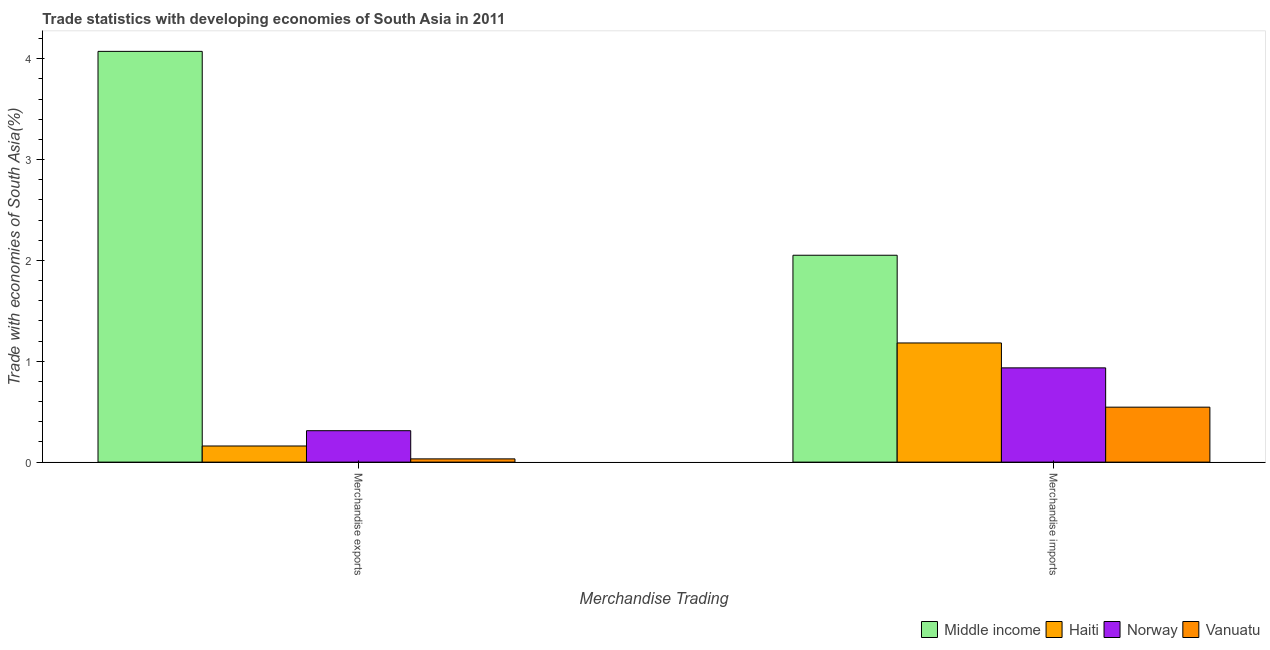Are the number of bars on each tick of the X-axis equal?
Make the answer very short. Yes. How many bars are there on the 2nd tick from the left?
Your answer should be very brief. 4. What is the label of the 1st group of bars from the left?
Keep it short and to the point. Merchandise exports. What is the merchandise exports in Norway?
Make the answer very short. 0.31. Across all countries, what is the maximum merchandise exports?
Provide a succinct answer. 4.07. Across all countries, what is the minimum merchandise exports?
Provide a succinct answer. 0.03. In which country was the merchandise imports minimum?
Offer a very short reply. Vanuatu. What is the total merchandise exports in the graph?
Keep it short and to the point. 4.58. What is the difference between the merchandise imports in Haiti and that in Middle income?
Ensure brevity in your answer.  -0.87. What is the difference between the merchandise exports in Vanuatu and the merchandise imports in Middle income?
Make the answer very short. -2.02. What is the average merchandise exports per country?
Ensure brevity in your answer.  1.14. What is the difference between the merchandise exports and merchandise imports in Middle income?
Offer a terse response. 2.02. What is the ratio of the merchandise imports in Vanuatu to that in Middle income?
Keep it short and to the point. 0.27. What does the 3rd bar from the right in Merchandise imports represents?
Your response must be concise. Haiti. How many countries are there in the graph?
Offer a very short reply. 4. Are the values on the major ticks of Y-axis written in scientific E-notation?
Ensure brevity in your answer.  No. Where does the legend appear in the graph?
Your answer should be very brief. Bottom right. How many legend labels are there?
Provide a short and direct response. 4. How are the legend labels stacked?
Offer a very short reply. Horizontal. What is the title of the graph?
Your answer should be compact. Trade statistics with developing economies of South Asia in 2011. What is the label or title of the X-axis?
Provide a short and direct response. Merchandise Trading. What is the label or title of the Y-axis?
Your answer should be very brief. Trade with economies of South Asia(%). What is the Trade with economies of South Asia(%) of Middle income in Merchandise exports?
Your answer should be very brief. 4.07. What is the Trade with economies of South Asia(%) of Haiti in Merchandise exports?
Ensure brevity in your answer.  0.16. What is the Trade with economies of South Asia(%) of Norway in Merchandise exports?
Your response must be concise. 0.31. What is the Trade with economies of South Asia(%) of Vanuatu in Merchandise exports?
Ensure brevity in your answer.  0.03. What is the Trade with economies of South Asia(%) in Middle income in Merchandise imports?
Ensure brevity in your answer.  2.05. What is the Trade with economies of South Asia(%) of Haiti in Merchandise imports?
Give a very brief answer. 1.18. What is the Trade with economies of South Asia(%) in Norway in Merchandise imports?
Provide a short and direct response. 0.93. What is the Trade with economies of South Asia(%) in Vanuatu in Merchandise imports?
Make the answer very short. 0.54. Across all Merchandise Trading, what is the maximum Trade with economies of South Asia(%) in Middle income?
Offer a terse response. 4.07. Across all Merchandise Trading, what is the maximum Trade with economies of South Asia(%) in Haiti?
Your answer should be compact. 1.18. Across all Merchandise Trading, what is the maximum Trade with economies of South Asia(%) in Norway?
Your response must be concise. 0.93. Across all Merchandise Trading, what is the maximum Trade with economies of South Asia(%) in Vanuatu?
Your answer should be very brief. 0.54. Across all Merchandise Trading, what is the minimum Trade with economies of South Asia(%) of Middle income?
Provide a short and direct response. 2.05. Across all Merchandise Trading, what is the minimum Trade with economies of South Asia(%) in Haiti?
Keep it short and to the point. 0.16. Across all Merchandise Trading, what is the minimum Trade with economies of South Asia(%) in Norway?
Your response must be concise. 0.31. Across all Merchandise Trading, what is the minimum Trade with economies of South Asia(%) in Vanuatu?
Make the answer very short. 0.03. What is the total Trade with economies of South Asia(%) of Middle income in the graph?
Make the answer very short. 6.13. What is the total Trade with economies of South Asia(%) in Haiti in the graph?
Provide a succinct answer. 1.34. What is the total Trade with economies of South Asia(%) in Norway in the graph?
Provide a short and direct response. 1.25. What is the total Trade with economies of South Asia(%) in Vanuatu in the graph?
Provide a succinct answer. 0.58. What is the difference between the Trade with economies of South Asia(%) of Middle income in Merchandise exports and that in Merchandise imports?
Provide a succinct answer. 2.02. What is the difference between the Trade with economies of South Asia(%) in Haiti in Merchandise exports and that in Merchandise imports?
Offer a very short reply. -1.02. What is the difference between the Trade with economies of South Asia(%) in Norway in Merchandise exports and that in Merchandise imports?
Make the answer very short. -0.62. What is the difference between the Trade with economies of South Asia(%) of Vanuatu in Merchandise exports and that in Merchandise imports?
Keep it short and to the point. -0.51. What is the difference between the Trade with economies of South Asia(%) in Middle income in Merchandise exports and the Trade with economies of South Asia(%) in Haiti in Merchandise imports?
Offer a very short reply. 2.89. What is the difference between the Trade with economies of South Asia(%) in Middle income in Merchandise exports and the Trade with economies of South Asia(%) in Norway in Merchandise imports?
Provide a short and direct response. 3.14. What is the difference between the Trade with economies of South Asia(%) in Middle income in Merchandise exports and the Trade with economies of South Asia(%) in Vanuatu in Merchandise imports?
Offer a terse response. 3.53. What is the difference between the Trade with economies of South Asia(%) of Haiti in Merchandise exports and the Trade with economies of South Asia(%) of Norway in Merchandise imports?
Make the answer very short. -0.77. What is the difference between the Trade with economies of South Asia(%) in Haiti in Merchandise exports and the Trade with economies of South Asia(%) in Vanuatu in Merchandise imports?
Ensure brevity in your answer.  -0.39. What is the difference between the Trade with economies of South Asia(%) in Norway in Merchandise exports and the Trade with economies of South Asia(%) in Vanuatu in Merchandise imports?
Provide a succinct answer. -0.23. What is the average Trade with economies of South Asia(%) of Middle income per Merchandise Trading?
Your answer should be compact. 3.06. What is the average Trade with economies of South Asia(%) in Haiti per Merchandise Trading?
Your answer should be compact. 0.67. What is the average Trade with economies of South Asia(%) of Norway per Merchandise Trading?
Your answer should be compact. 0.62. What is the average Trade with economies of South Asia(%) in Vanuatu per Merchandise Trading?
Your response must be concise. 0.29. What is the difference between the Trade with economies of South Asia(%) of Middle income and Trade with economies of South Asia(%) of Haiti in Merchandise exports?
Make the answer very short. 3.91. What is the difference between the Trade with economies of South Asia(%) in Middle income and Trade with economies of South Asia(%) in Norway in Merchandise exports?
Provide a succinct answer. 3.76. What is the difference between the Trade with economies of South Asia(%) of Middle income and Trade with economies of South Asia(%) of Vanuatu in Merchandise exports?
Offer a terse response. 4.04. What is the difference between the Trade with economies of South Asia(%) of Haiti and Trade with economies of South Asia(%) of Norway in Merchandise exports?
Provide a succinct answer. -0.15. What is the difference between the Trade with economies of South Asia(%) in Haiti and Trade with economies of South Asia(%) in Vanuatu in Merchandise exports?
Offer a very short reply. 0.13. What is the difference between the Trade with economies of South Asia(%) of Norway and Trade with economies of South Asia(%) of Vanuatu in Merchandise exports?
Your response must be concise. 0.28. What is the difference between the Trade with economies of South Asia(%) in Middle income and Trade with economies of South Asia(%) in Haiti in Merchandise imports?
Your answer should be very brief. 0.87. What is the difference between the Trade with economies of South Asia(%) in Middle income and Trade with economies of South Asia(%) in Norway in Merchandise imports?
Provide a succinct answer. 1.12. What is the difference between the Trade with economies of South Asia(%) of Middle income and Trade with economies of South Asia(%) of Vanuatu in Merchandise imports?
Keep it short and to the point. 1.51. What is the difference between the Trade with economies of South Asia(%) in Haiti and Trade with economies of South Asia(%) in Norway in Merchandise imports?
Provide a short and direct response. 0.25. What is the difference between the Trade with economies of South Asia(%) in Haiti and Trade with economies of South Asia(%) in Vanuatu in Merchandise imports?
Ensure brevity in your answer.  0.64. What is the difference between the Trade with economies of South Asia(%) in Norway and Trade with economies of South Asia(%) in Vanuatu in Merchandise imports?
Your response must be concise. 0.39. What is the ratio of the Trade with economies of South Asia(%) in Middle income in Merchandise exports to that in Merchandise imports?
Offer a terse response. 1.99. What is the ratio of the Trade with economies of South Asia(%) in Haiti in Merchandise exports to that in Merchandise imports?
Ensure brevity in your answer.  0.14. What is the ratio of the Trade with economies of South Asia(%) of Norway in Merchandise exports to that in Merchandise imports?
Provide a succinct answer. 0.33. What is the ratio of the Trade with economies of South Asia(%) of Vanuatu in Merchandise exports to that in Merchandise imports?
Provide a succinct answer. 0.06. What is the difference between the highest and the second highest Trade with economies of South Asia(%) in Middle income?
Give a very brief answer. 2.02. What is the difference between the highest and the second highest Trade with economies of South Asia(%) in Haiti?
Provide a short and direct response. 1.02. What is the difference between the highest and the second highest Trade with economies of South Asia(%) of Norway?
Give a very brief answer. 0.62. What is the difference between the highest and the second highest Trade with economies of South Asia(%) of Vanuatu?
Your answer should be compact. 0.51. What is the difference between the highest and the lowest Trade with economies of South Asia(%) of Middle income?
Your answer should be very brief. 2.02. What is the difference between the highest and the lowest Trade with economies of South Asia(%) of Haiti?
Make the answer very short. 1.02. What is the difference between the highest and the lowest Trade with economies of South Asia(%) in Norway?
Your answer should be compact. 0.62. What is the difference between the highest and the lowest Trade with economies of South Asia(%) of Vanuatu?
Offer a very short reply. 0.51. 